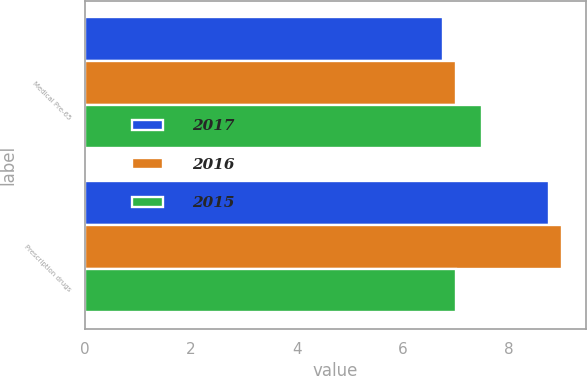Convert chart. <chart><loc_0><loc_0><loc_500><loc_500><stacked_bar_chart><ecel><fcel>Medical Pre-65<fcel>Prescription drugs<nl><fcel>2017<fcel>6.75<fcel>8.75<nl><fcel>2016<fcel>7<fcel>9<nl><fcel>2015<fcel>7.5<fcel>7<nl></chart> 